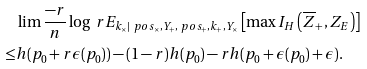<formula> <loc_0><loc_0><loc_500><loc_500>& \lim \frac { - r } { n } \log \ r E _ { k _ { \times } | \ p o s _ { \times } , Y _ { + } , \ p o s _ { + } , k _ { + } , Y _ { \times } } \left [ \max I _ { H } \left ( \overline { Z } _ { + } , Z _ { E } \right ) \right ] \\ \leq & h ( p _ { 0 } + r \epsilon ( p _ { 0 } ) ) - ( 1 - r ) h ( p _ { 0 } ) - r h ( p _ { 0 } + \epsilon ( p _ { 0 } ) + \epsilon ) .</formula> 